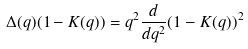Convert formula to latex. <formula><loc_0><loc_0><loc_500><loc_500>\Delta ( q ) ( 1 - K ( q ) ) = q ^ { 2 } \frac { d } { d q ^ { 2 } } ( 1 - K ( q ) ) ^ { 2 }</formula> 